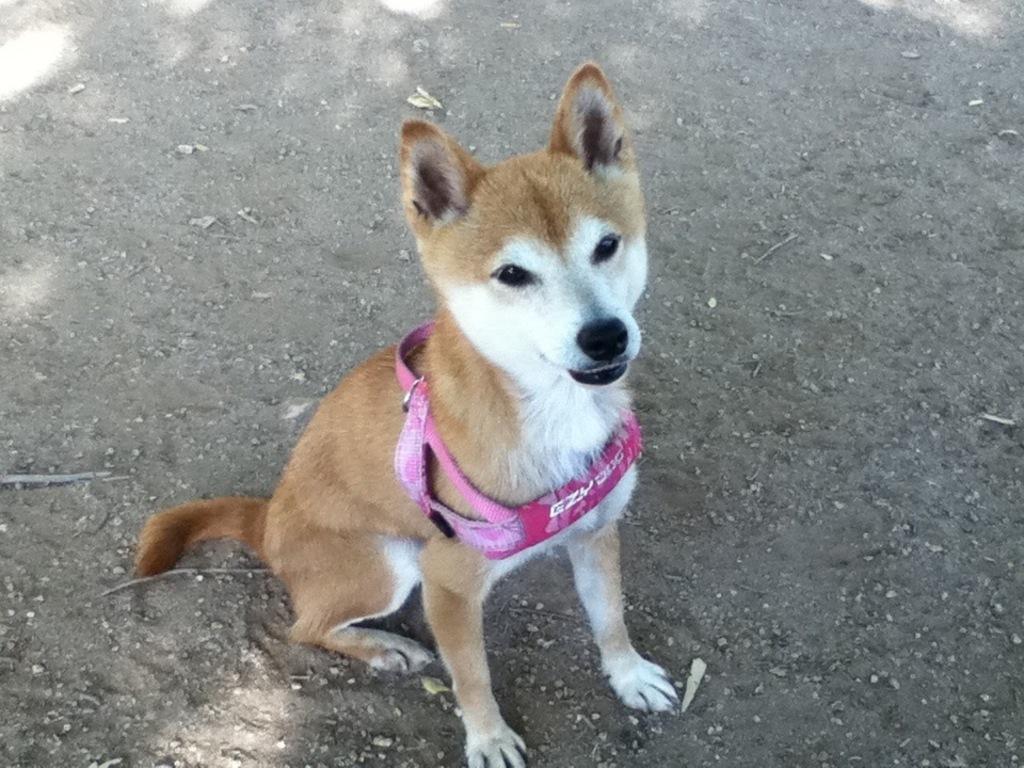How would you summarize this image in a sentence or two? In this image I can see the dog which is in white and brown color. It is having the pink color belt. It is on the ground. 